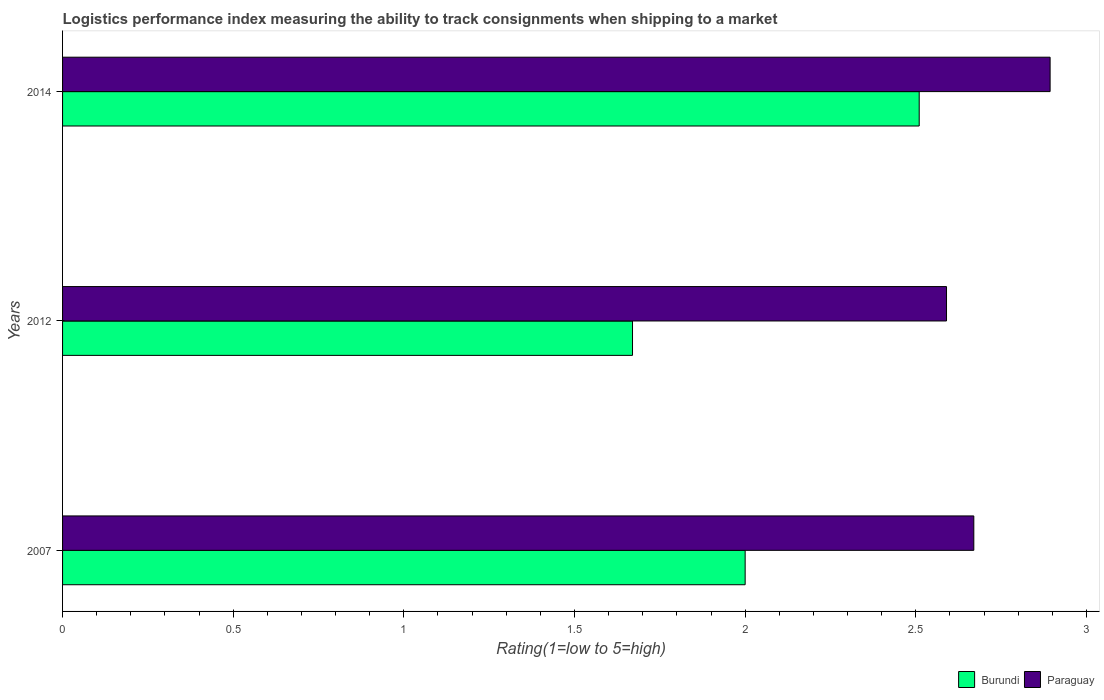How many groups of bars are there?
Keep it short and to the point. 3. Are the number of bars per tick equal to the number of legend labels?
Provide a succinct answer. Yes. Are the number of bars on each tick of the Y-axis equal?
Your answer should be very brief. Yes. How many bars are there on the 3rd tick from the top?
Keep it short and to the point. 2. How many bars are there on the 2nd tick from the bottom?
Provide a short and direct response. 2. What is the label of the 3rd group of bars from the top?
Give a very brief answer. 2007. In how many cases, is the number of bars for a given year not equal to the number of legend labels?
Your answer should be very brief. 0. Across all years, what is the maximum Logistic performance index in Burundi?
Offer a very short reply. 2.51. Across all years, what is the minimum Logistic performance index in Paraguay?
Offer a very short reply. 2.59. In which year was the Logistic performance index in Paraguay maximum?
Keep it short and to the point. 2014. What is the total Logistic performance index in Burundi in the graph?
Your response must be concise. 6.18. What is the difference between the Logistic performance index in Burundi in 2012 and that in 2014?
Ensure brevity in your answer.  -0.84. What is the difference between the Logistic performance index in Burundi in 2007 and the Logistic performance index in Paraguay in 2012?
Give a very brief answer. -0.59. What is the average Logistic performance index in Burundi per year?
Keep it short and to the point. 2.06. In the year 2012, what is the difference between the Logistic performance index in Paraguay and Logistic performance index in Burundi?
Your answer should be compact. 0.92. In how many years, is the Logistic performance index in Paraguay greater than 2.3 ?
Your answer should be compact. 3. What is the ratio of the Logistic performance index in Paraguay in 2007 to that in 2012?
Make the answer very short. 1.03. What is the difference between the highest and the second highest Logistic performance index in Burundi?
Give a very brief answer. 0.51. What is the difference between the highest and the lowest Logistic performance index in Burundi?
Your answer should be very brief. 0.84. In how many years, is the Logistic performance index in Burundi greater than the average Logistic performance index in Burundi taken over all years?
Ensure brevity in your answer.  1. What does the 2nd bar from the top in 2014 represents?
Your answer should be compact. Burundi. What does the 1st bar from the bottom in 2007 represents?
Your response must be concise. Burundi. Are all the bars in the graph horizontal?
Provide a succinct answer. Yes. How many years are there in the graph?
Offer a very short reply. 3. What is the difference between two consecutive major ticks on the X-axis?
Your response must be concise. 0.5. Does the graph contain any zero values?
Keep it short and to the point. No. Where does the legend appear in the graph?
Ensure brevity in your answer.  Bottom right. How are the legend labels stacked?
Provide a short and direct response. Horizontal. What is the title of the graph?
Your response must be concise. Logistics performance index measuring the ability to track consignments when shipping to a market. Does "Indonesia" appear as one of the legend labels in the graph?
Offer a very short reply. No. What is the label or title of the X-axis?
Ensure brevity in your answer.  Rating(1=low to 5=high). What is the Rating(1=low to 5=high) in Burundi in 2007?
Give a very brief answer. 2. What is the Rating(1=low to 5=high) of Paraguay in 2007?
Make the answer very short. 2.67. What is the Rating(1=low to 5=high) of Burundi in 2012?
Your answer should be compact. 1.67. What is the Rating(1=low to 5=high) in Paraguay in 2012?
Offer a very short reply. 2.59. What is the Rating(1=low to 5=high) of Burundi in 2014?
Give a very brief answer. 2.51. What is the Rating(1=low to 5=high) in Paraguay in 2014?
Provide a short and direct response. 2.89. Across all years, what is the maximum Rating(1=low to 5=high) in Burundi?
Keep it short and to the point. 2.51. Across all years, what is the maximum Rating(1=low to 5=high) in Paraguay?
Keep it short and to the point. 2.89. Across all years, what is the minimum Rating(1=low to 5=high) in Burundi?
Ensure brevity in your answer.  1.67. Across all years, what is the minimum Rating(1=low to 5=high) in Paraguay?
Your response must be concise. 2.59. What is the total Rating(1=low to 5=high) in Burundi in the graph?
Give a very brief answer. 6.18. What is the total Rating(1=low to 5=high) in Paraguay in the graph?
Make the answer very short. 8.15. What is the difference between the Rating(1=low to 5=high) of Burundi in 2007 and that in 2012?
Your response must be concise. 0.33. What is the difference between the Rating(1=low to 5=high) of Paraguay in 2007 and that in 2012?
Your answer should be very brief. 0.08. What is the difference between the Rating(1=low to 5=high) of Burundi in 2007 and that in 2014?
Make the answer very short. -0.51. What is the difference between the Rating(1=low to 5=high) in Paraguay in 2007 and that in 2014?
Give a very brief answer. -0.22. What is the difference between the Rating(1=low to 5=high) in Burundi in 2012 and that in 2014?
Give a very brief answer. -0.84. What is the difference between the Rating(1=low to 5=high) in Paraguay in 2012 and that in 2014?
Give a very brief answer. -0.3. What is the difference between the Rating(1=low to 5=high) in Burundi in 2007 and the Rating(1=low to 5=high) in Paraguay in 2012?
Ensure brevity in your answer.  -0.59. What is the difference between the Rating(1=low to 5=high) in Burundi in 2007 and the Rating(1=low to 5=high) in Paraguay in 2014?
Give a very brief answer. -0.89. What is the difference between the Rating(1=low to 5=high) of Burundi in 2012 and the Rating(1=low to 5=high) of Paraguay in 2014?
Make the answer very short. -1.22. What is the average Rating(1=low to 5=high) in Burundi per year?
Keep it short and to the point. 2.06. What is the average Rating(1=low to 5=high) of Paraguay per year?
Offer a terse response. 2.72. In the year 2007, what is the difference between the Rating(1=low to 5=high) of Burundi and Rating(1=low to 5=high) of Paraguay?
Keep it short and to the point. -0.67. In the year 2012, what is the difference between the Rating(1=low to 5=high) of Burundi and Rating(1=low to 5=high) of Paraguay?
Provide a succinct answer. -0.92. In the year 2014, what is the difference between the Rating(1=low to 5=high) of Burundi and Rating(1=low to 5=high) of Paraguay?
Make the answer very short. -0.38. What is the ratio of the Rating(1=low to 5=high) of Burundi in 2007 to that in 2012?
Offer a very short reply. 1.2. What is the ratio of the Rating(1=low to 5=high) of Paraguay in 2007 to that in 2012?
Keep it short and to the point. 1.03. What is the ratio of the Rating(1=low to 5=high) in Burundi in 2007 to that in 2014?
Provide a succinct answer. 0.8. What is the ratio of the Rating(1=low to 5=high) in Paraguay in 2007 to that in 2014?
Provide a short and direct response. 0.92. What is the ratio of the Rating(1=low to 5=high) of Burundi in 2012 to that in 2014?
Provide a succinct answer. 0.67. What is the ratio of the Rating(1=low to 5=high) in Paraguay in 2012 to that in 2014?
Your answer should be very brief. 0.9. What is the difference between the highest and the second highest Rating(1=low to 5=high) in Burundi?
Keep it short and to the point. 0.51. What is the difference between the highest and the second highest Rating(1=low to 5=high) of Paraguay?
Your answer should be compact. 0.22. What is the difference between the highest and the lowest Rating(1=low to 5=high) of Burundi?
Offer a very short reply. 0.84. What is the difference between the highest and the lowest Rating(1=low to 5=high) in Paraguay?
Your answer should be compact. 0.3. 